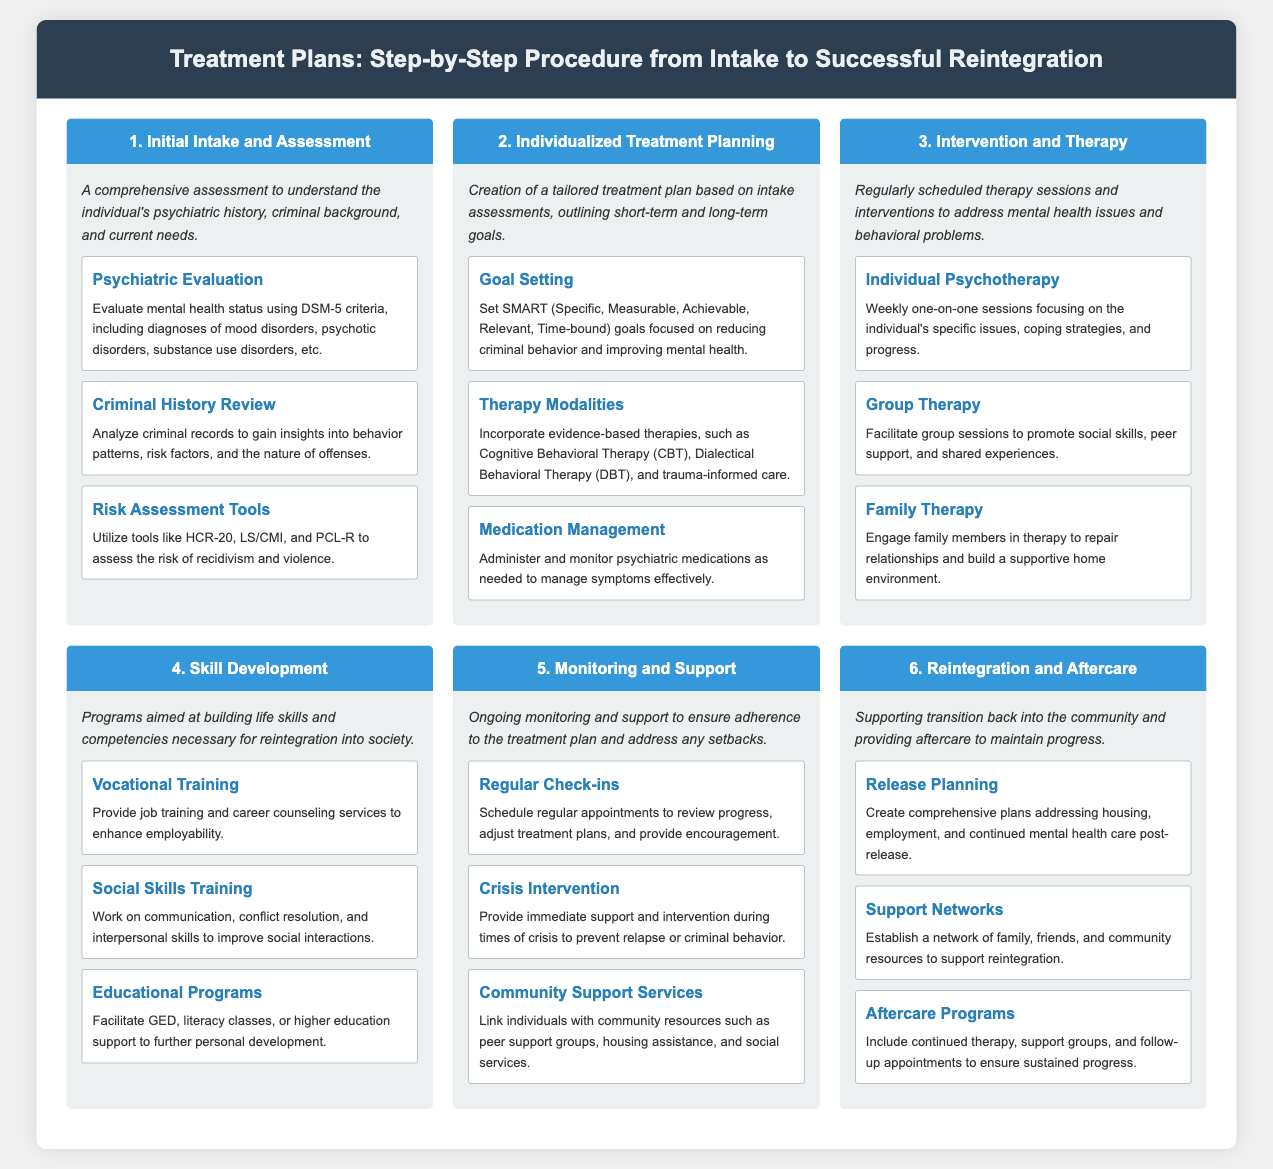What is the first step of the treatment plan? The first step is "Initial Intake and Assessment," which includes a comprehensive assessment of the individual's psychiatric history, criminal background, and current needs.
Answer: Initial Intake and Assessment How many therapy modalities are included in individualized treatment planning? The document mentions three therapy modalities: Cognitive Behavioral Therapy (CBT), Dialectical Behavioral Therapy (DBT), and trauma-informed care.
Answer: Three What type of training is provided under skill development? The document specifies "Vocational Training," which provides job training and career counseling services to enhance employability.
Answer: Vocational Training What is the purpose of crisis intervention? Crisis intervention provides immediate support and intervention during times of crisis to prevent relapse or criminal behavior, as indicated in the document.
Answer: Immediate support Which component focuses on communication and conflict resolution? "Social Skills Training" is the component focused on communication, conflict resolution, and interpersonal skills to improve social interactions.
Answer: Social Skills Training What is the last step in the treatment plan? The last step is "Reintegration and Aftercare," outlining support for transitioning back into the community and aftercare to maintain progress.
Answer: Reintegration and Aftercare Name one risk assessment tool mentioned in the document. The document mentions several tools, one of which is the HCR-20, used to assess the risk of recidivism and violence.
Answer: HCR-20 What is the main focus of the family therapy component? The main focus of family therapy is to engage family members in therapy to repair relationships and build a supportive home environment.
Answer: Repair relationships What type of support services link individuals with community resources? "Community Support Services" link individuals with peer support groups, housing assistance, and social services as mentioned in the document.
Answer: Community Support Services 